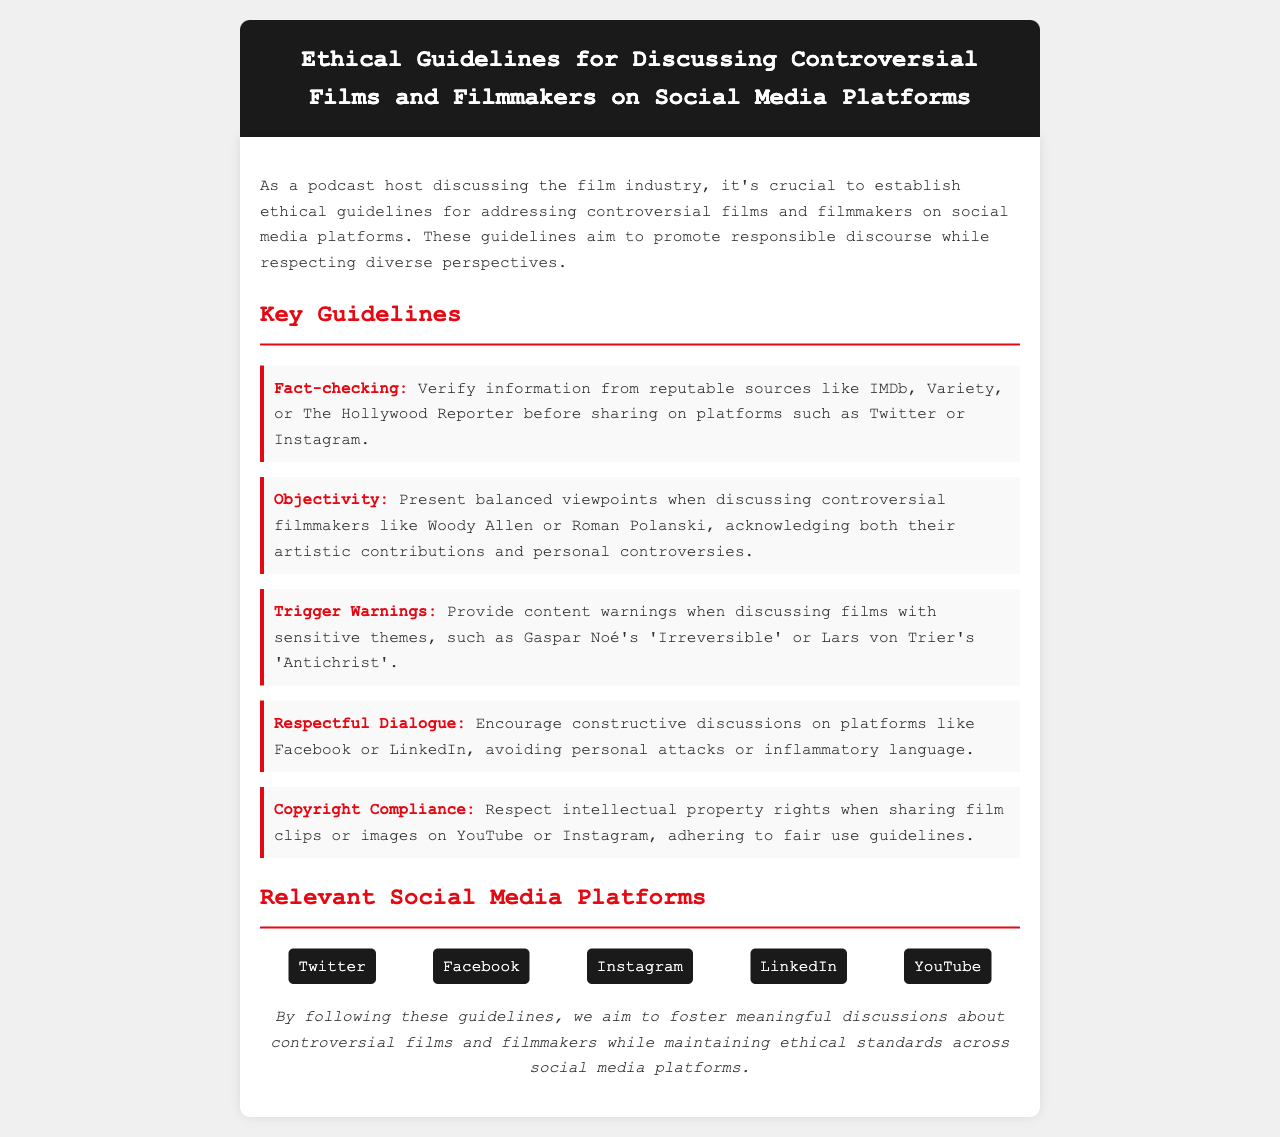What is the title of the document? The title of the document is stated in the header section.
Answer: Ethical Guidelines for Discussing Controversial Films and Filmmakers on Social Media Platforms What is one key guideline regarding information sharing? The guideline about information sharing can be found in the list of key guidelines.
Answer: Fact-checking Which filmmaker is mentioned as an example in the guideline about objectivity? The document provides examples of controversial filmmakers under the objectivity guideline.
Answer: Woody Allen What should be provided when discussing films with sensitive themes? The document specifies a requirement related to content warnings in the relevant key guideline.
Answer: Trigger Warnings Name one social media platform mentioned in the document. The document lists several social media platforms where the guidelines apply.
Answer: Twitter How many key guidelines are provided in the document? The total count of the guidelines can be deduced from the listed items under key guidelines.
Answer: Five What is the overall purpose of these ethical guidelines? The purpose is articulated in the introductory paragraph of the content section.
Answer: Promote responsible discourse Which key guideline highlights the importance of respectful conversation? This guideline is explicitly mentioned in the list of key guidelines.
Answer: Respectful Dialogue 